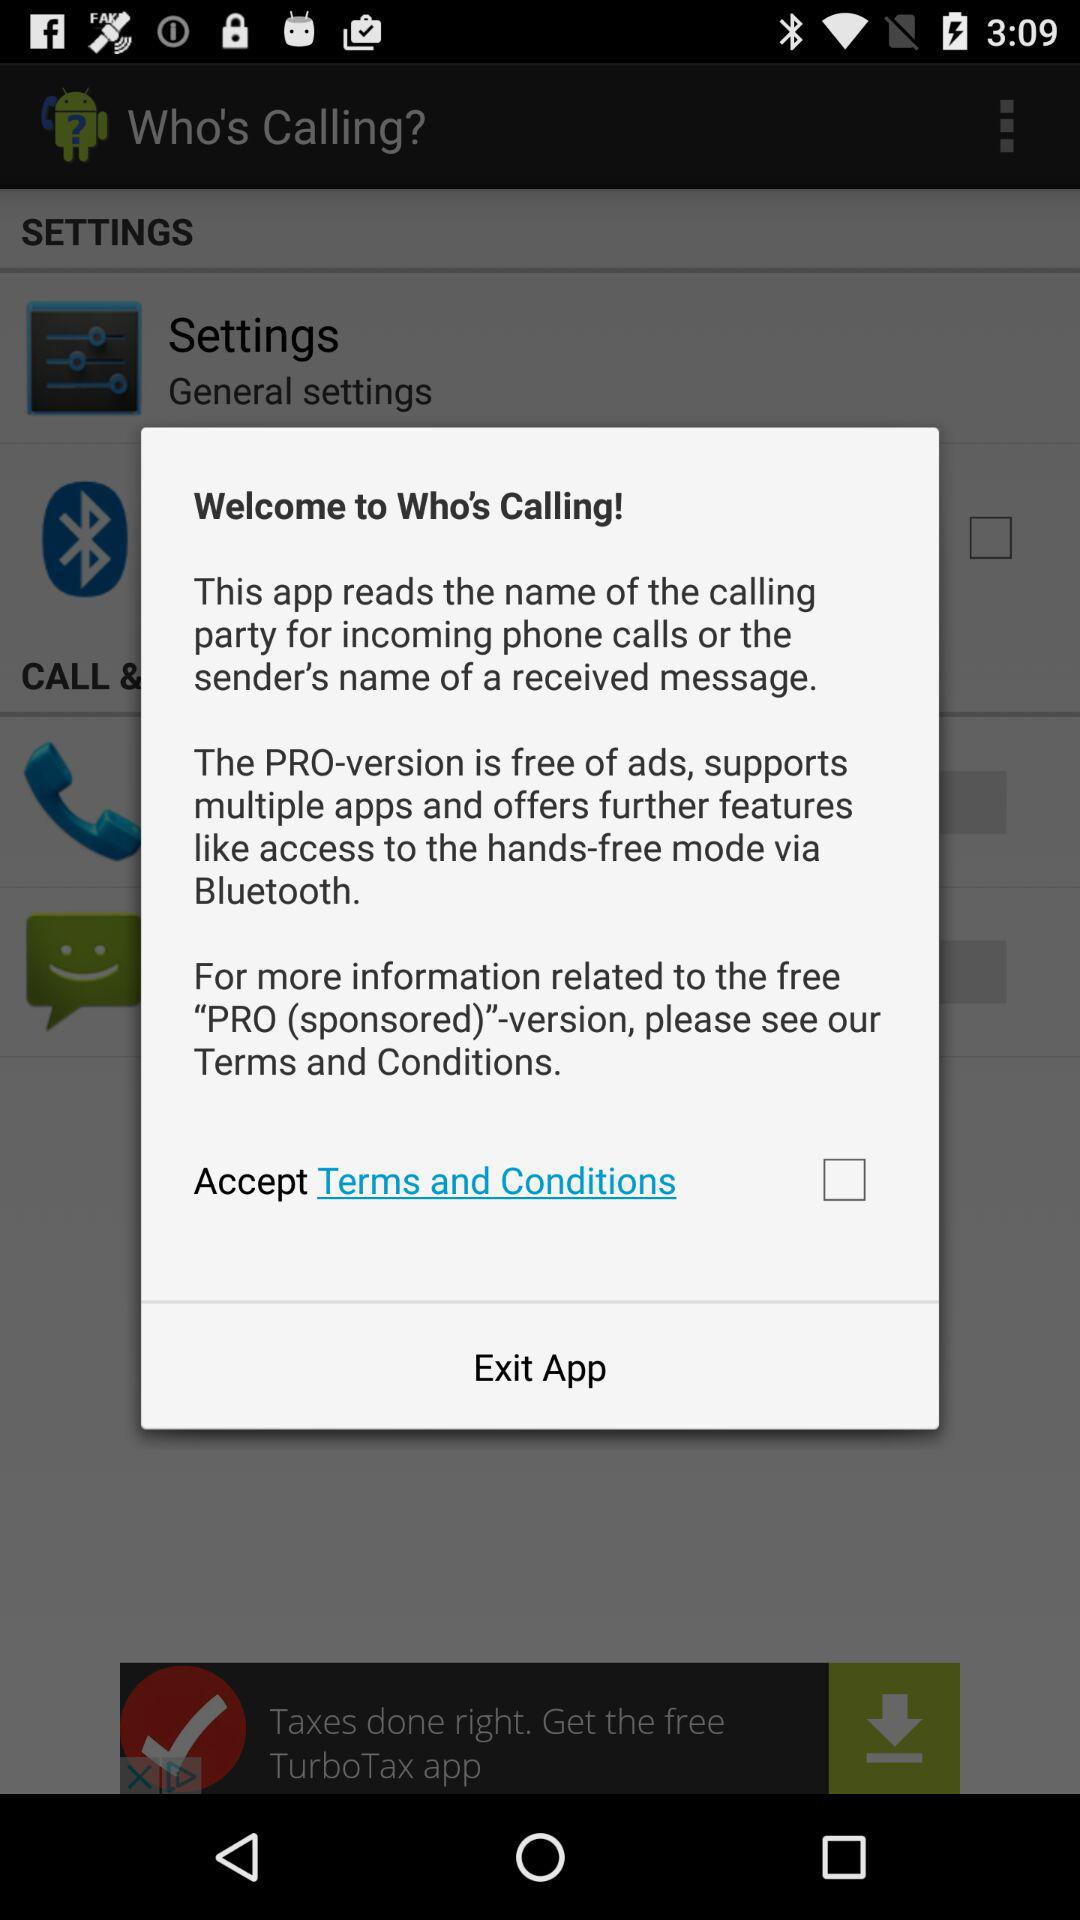What is the status of the option that includes acceptance to the “Terms and Conditions”? The status is "off". 